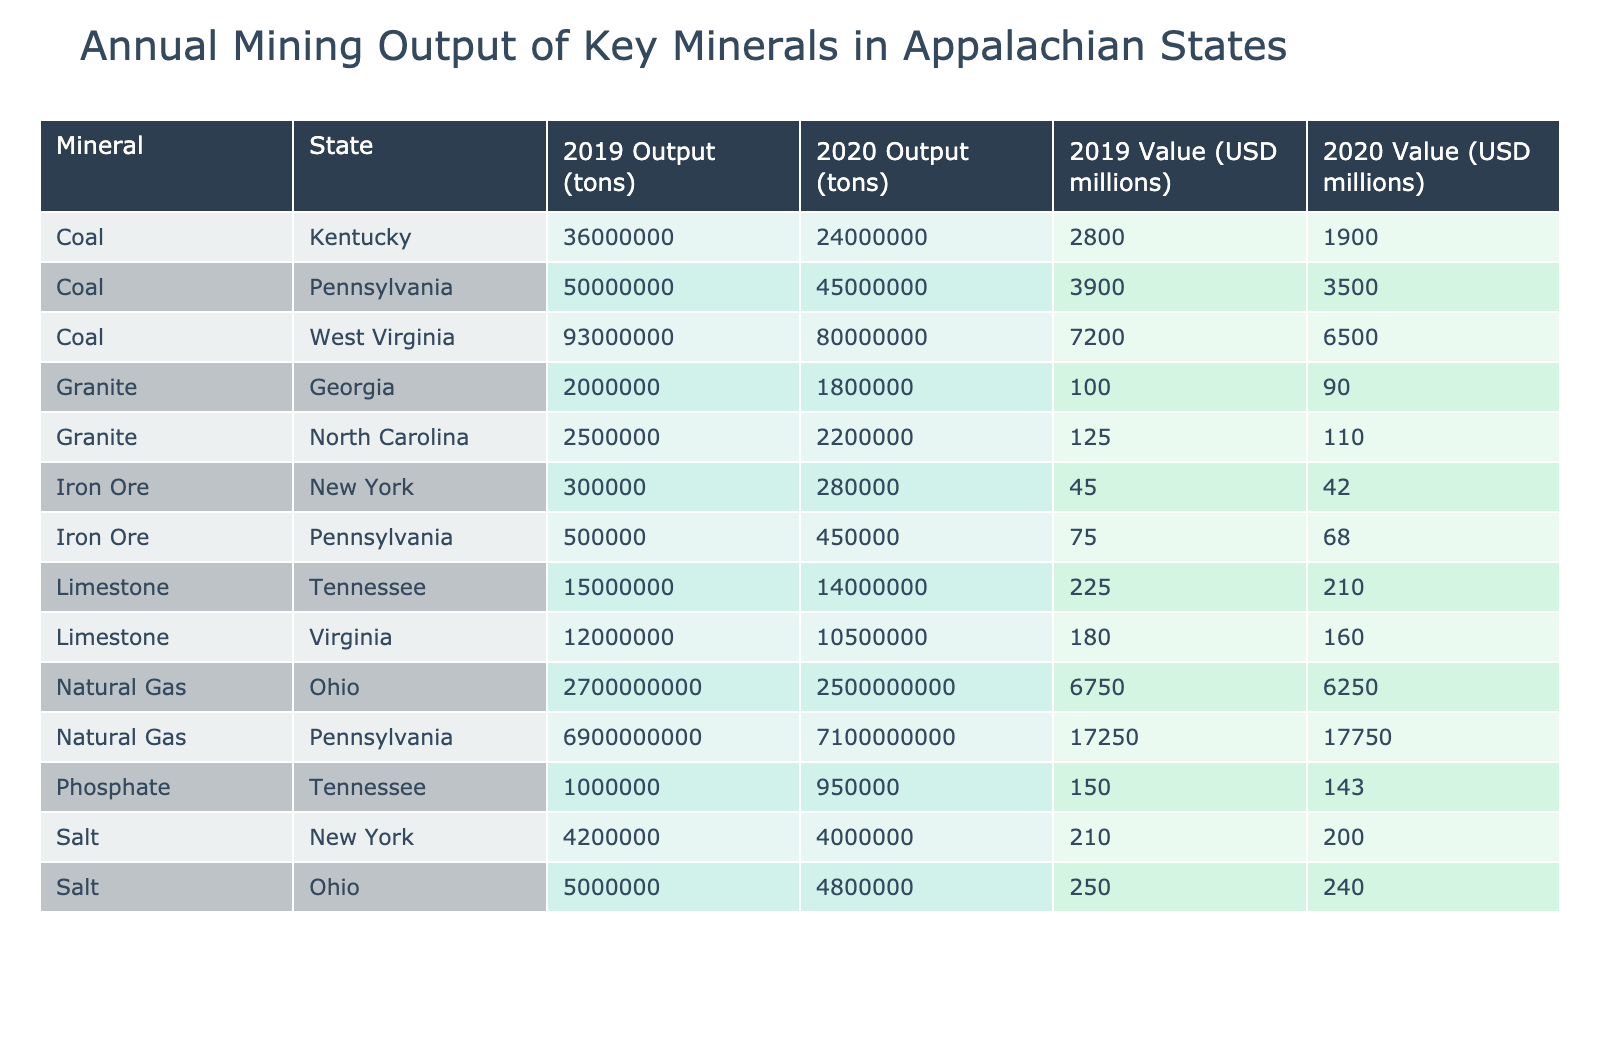What is the total coal output from West Virginia in 2020? In the table, the output for coal in West Virginia for the year 2020 is listed as 80,000,000 tons. This is a direct retrieval question where we simply look for the specific value under the relevant headings.
Answer: 80,000,000 tons Which state produced the highest natural gas output in 2019? The table indicates that Pennsylvania produced 6,900,000,000 tons of natural gas in 2019, which is the highest among the states listed for that year. This is a straightforward fact retrieval from the table itself.
Answer: Pennsylvania What is the difference in limestone output between Virginia in 2019 and 2020? For Virginia, the limestone output in 2019 is 12,000,000 tons and in 2020 it is 10,500,000 tons. The difference is 12,000,000 - 10,500,000 = 1,500,000 tons. Thus, we first identify the values for the respective years and then carry out the subtraction.
Answer: 1,500,000 tons Is the value of iron ore produced in New York higher in 2019 than in 2020? In the table, the value of iron ore produced in New York is 45 million USD in 2019 and 42 million USD in 2020. Since 45 million is greater than 42 million, this statement is true. We compare the respective values directly to answer.
Answer: Yes What is the average output of granite across both years for North Carolina? For North Carolina, the granite outputs are 2,500,000 tons in 2019 and 2,200,000 tons in 2020. The total output is 2,500,000 + 2,200,000 = 4,700,000 tons. To find the average, we divide by 2, resulting in 4,700,000 / 2 = 2,350,000 tons. Hence, we ensure that we collect all relevant data points before calculating the average.
Answer: 2,350,000 tons Which mineral had the highest combined output across both years in Pennsylvania? In Pennsylvania, coal had an output of 50,000,000 tons in 2019 and 45,000,000 tons in 2020, totaling 95,000,000 tons. Natural gas produced 6,900,000,000 tons in 2019 and 7,100,000,000 tons in 2020, totaling 14,000,000,000 tons. Comparing these sums, natural gas has a significantly higher total, surpassing that of coal. We compare the sums to answer the question accurately.
Answer: Natural Gas 